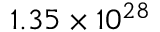Convert formula to latex. <formula><loc_0><loc_0><loc_500><loc_500>1 . 3 5 \times 1 0 ^ { 2 8 }</formula> 